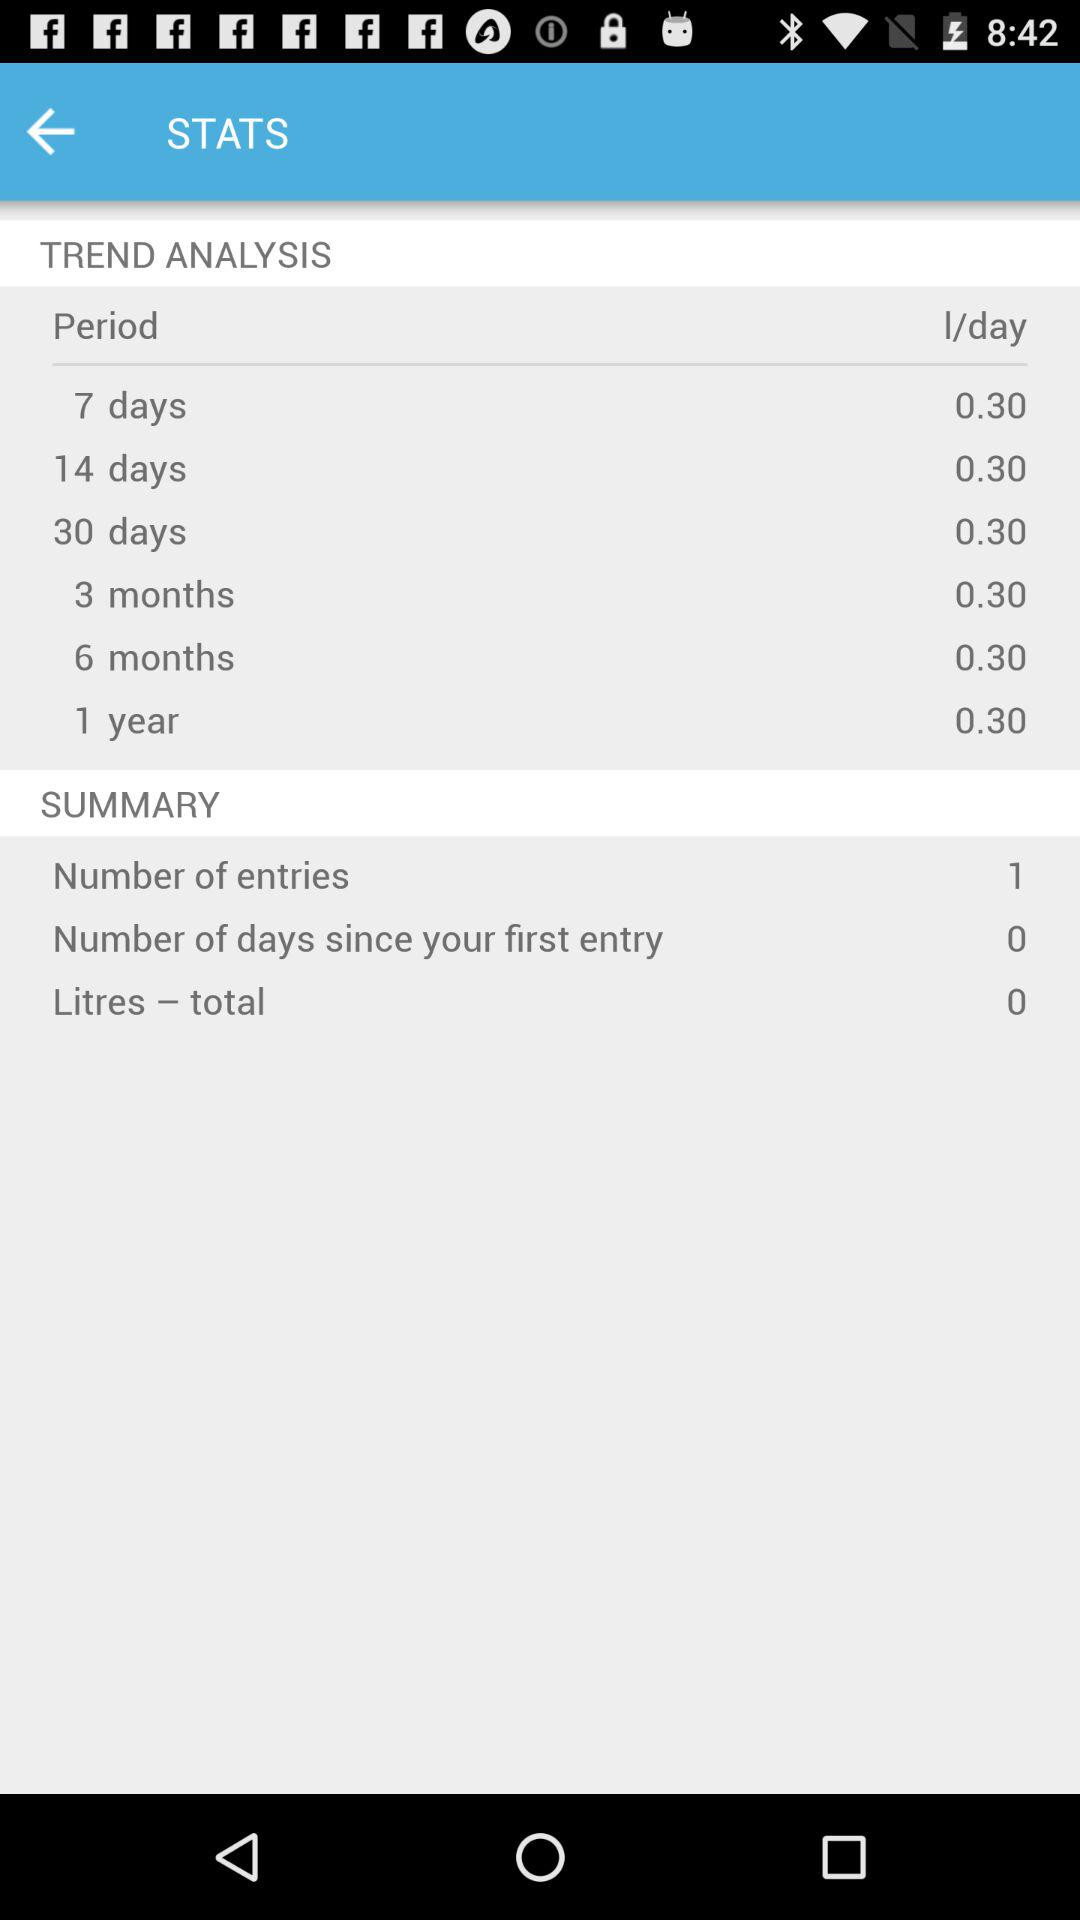How many l/day are there in a 7 day period? There are 0.30 l/day. 